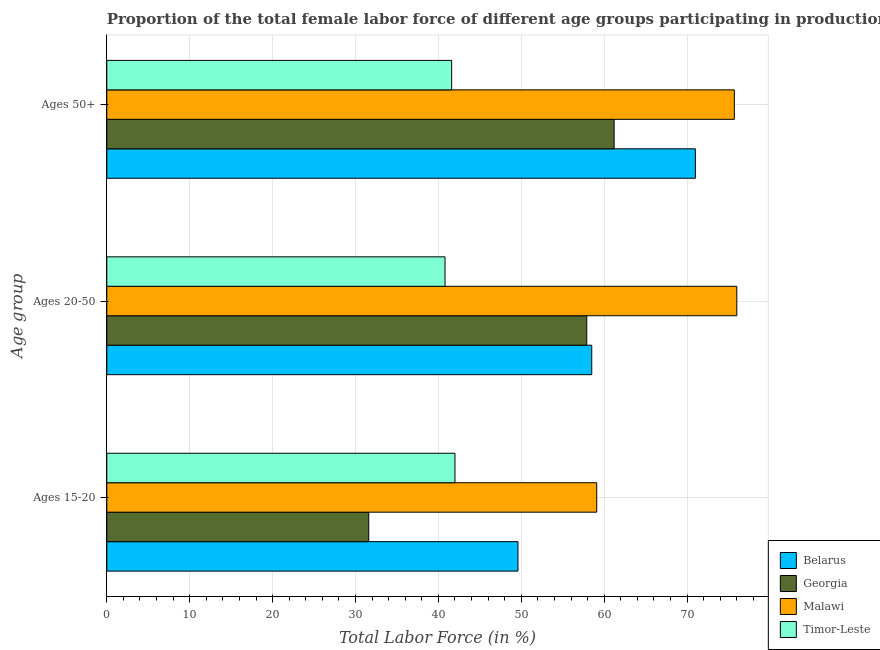Are the number of bars per tick equal to the number of legend labels?
Provide a succinct answer. Yes. How many bars are there on the 3rd tick from the bottom?
Your answer should be very brief. 4. What is the label of the 2nd group of bars from the top?
Make the answer very short. Ages 20-50. What is the percentage of female labor force above age 50 in Georgia?
Offer a very short reply. 61.2. Across all countries, what is the maximum percentage of female labor force within the age group 20-50?
Offer a terse response. 76. Across all countries, what is the minimum percentage of female labor force within the age group 20-50?
Offer a terse response. 40.8. In which country was the percentage of female labor force within the age group 15-20 maximum?
Offer a terse response. Malawi. In which country was the percentage of female labor force within the age group 15-20 minimum?
Provide a short and direct response. Georgia. What is the total percentage of female labor force within the age group 20-50 in the graph?
Make the answer very short. 233.2. What is the difference between the percentage of female labor force above age 50 in Georgia and that in Malawi?
Give a very brief answer. -14.5. What is the difference between the percentage of female labor force above age 50 in Timor-Leste and the percentage of female labor force within the age group 15-20 in Georgia?
Provide a succinct answer. 10. What is the average percentage of female labor force above age 50 per country?
Offer a very short reply. 62.37. In how many countries, is the percentage of female labor force within the age group 15-20 greater than 42 %?
Ensure brevity in your answer.  2. What is the ratio of the percentage of female labor force above age 50 in Belarus to that in Malawi?
Your answer should be very brief. 0.94. Is the percentage of female labor force within the age group 20-50 in Timor-Leste less than that in Georgia?
Your answer should be very brief. Yes. Is the difference between the percentage of female labor force within the age group 20-50 in Belarus and Malawi greater than the difference between the percentage of female labor force within the age group 15-20 in Belarus and Malawi?
Keep it short and to the point. No. What is the difference between the highest and the second highest percentage of female labor force above age 50?
Offer a very short reply. 4.7. What is the difference between the highest and the lowest percentage of female labor force within the age group 20-50?
Keep it short and to the point. 35.2. What does the 1st bar from the top in Ages 20-50 represents?
Make the answer very short. Timor-Leste. What does the 3rd bar from the bottom in Ages 15-20 represents?
Your answer should be very brief. Malawi. How many bars are there?
Your response must be concise. 12. How many countries are there in the graph?
Make the answer very short. 4. What is the difference between two consecutive major ticks on the X-axis?
Provide a short and direct response. 10. Are the values on the major ticks of X-axis written in scientific E-notation?
Offer a terse response. No. Does the graph contain grids?
Give a very brief answer. Yes. How many legend labels are there?
Ensure brevity in your answer.  4. How are the legend labels stacked?
Ensure brevity in your answer.  Vertical. What is the title of the graph?
Make the answer very short. Proportion of the total female labor force of different age groups participating in production in 1992. What is the label or title of the Y-axis?
Make the answer very short. Age group. What is the Total Labor Force (in %) of Belarus in Ages 15-20?
Keep it short and to the point. 49.6. What is the Total Labor Force (in %) of Georgia in Ages 15-20?
Offer a very short reply. 31.6. What is the Total Labor Force (in %) in Malawi in Ages 15-20?
Make the answer very short. 59.1. What is the Total Labor Force (in %) of Belarus in Ages 20-50?
Offer a terse response. 58.5. What is the Total Labor Force (in %) in Georgia in Ages 20-50?
Offer a very short reply. 57.9. What is the Total Labor Force (in %) in Timor-Leste in Ages 20-50?
Provide a short and direct response. 40.8. What is the Total Labor Force (in %) in Georgia in Ages 50+?
Your answer should be very brief. 61.2. What is the Total Labor Force (in %) in Malawi in Ages 50+?
Offer a very short reply. 75.7. What is the Total Labor Force (in %) in Timor-Leste in Ages 50+?
Provide a short and direct response. 41.6. Across all Age group, what is the maximum Total Labor Force (in %) in Belarus?
Give a very brief answer. 71. Across all Age group, what is the maximum Total Labor Force (in %) in Georgia?
Make the answer very short. 61.2. Across all Age group, what is the maximum Total Labor Force (in %) of Malawi?
Ensure brevity in your answer.  76. Across all Age group, what is the minimum Total Labor Force (in %) of Belarus?
Your answer should be very brief. 49.6. Across all Age group, what is the minimum Total Labor Force (in %) in Georgia?
Your answer should be compact. 31.6. Across all Age group, what is the minimum Total Labor Force (in %) of Malawi?
Ensure brevity in your answer.  59.1. Across all Age group, what is the minimum Total Labor Force (in %) in Timor-Leste?
Ensure brevity in your answer.  40.8. What is the total Total Labor Force (in %) in Belarus in the graph?
Make the answer very short. 179.1. What is the total Total Labor Force (in %) in Georgia in the graph?
Give a very brief answer. 150.7. What is the total Total Labor Force (in %) in Malawi in the graph?
Your answer should be very brief. 210.8. What is the total Total Labor Force (in %) in Timor-Leste in the graph?
Make the answer very short. 124.4. What is the difference between the Total Labor Force (in %) of Belarus in Ages 15-20 and that in Ages 20-50?
Ensure brevity in your answer.  -8.9. What is the difference between the Total Labor Force (in %) of Georgia in Ages 15-20 and that in Ages 20-50?
Make the answer very short. -26.3. What is the difference between the Total Labor Force (in %) of Malawi in Ages 15-20 and that in Ages 20-50?
Offer a terse response. -16.9. What is the difference between the Total Labor Force (in %) in Timor-Leste in Ages 15-20 and that in Ages 20-50?
Give a very brief answer. 1.2. What is the difference between the Total Labor Force (in %) in Belarus in Ages 15-20 and that in Ages 50+?
Offer a very short reply. -21.4. What is the difference between the Total Labor Force (in %) in Georgia in Ages 15-20 and that in Ages 50+?
Your answer should be compact. -29.6. What is the difference between the Total Labor Force (in %) in Malawi in Ages 15-20 and that in Ages 50+?
Provide a short and direct response. -16.6. What is the difference between the Total Labor Force (in %) in Malawi in Ages 20-50 and that in Ages 50+?
Your response must be concise. 0.3. What is the difference between the Total Labor Force (in %) in Belarus in Ages 15-20 and the Total Labor Force (in %) in Georgia in Ages 20-50?
Provide a succinct answer. -8.3. What is the difference between the Total Labor Force (in %) of Belarus in Ages 15-20 and the Total Labor Force (in %) of Malawi in Ages 20-50?
Make the answer very short. -26.4. What is the difference between the Total Labor Force (in %) in Georgia in Ages 15-20 and the Total Labor Force (in %) in Malawi in Ages 20-50?
Your answer should be very brief. -44.4. What is the difference between the Total Labor Force (in %) of Georgia in Ages 15-20 and the Total Labor Force (in %) of Timor-Leste in Ages 20-50?
Make the answer very short. -9.2. What is the difference between the Total Labor Force (in %) of Belarus in Ages 15-20 and the Total Labor Force (in %) of Georgia in Ages 50+?
Provide a short and direct response. -11.6. What is the difference between the Total Labor Force (in %) of Belarus in Ages 15-20 and the Total Labor Force (in %) of Malawi in Ages 50+?
Provide a succinct answer. -26.1. What is the difference between the Total Labor Force (in %) of Georgia in Ages 15-20 and the Total Labor Force (in %) of Malawi in Ages 50+?
Your answer should be very brief. -44.1. What is the difference between the Total Labor Force (in %) in Georgia in Ages 15-20 and the Total Labor Force (in %) in Timor-Leste in Ages 50+?
Your answer should be very brief. -10. What is the difference between the Total Labor Force (in %) in Malawi in Ages 15-20 and the Total Labor Force (in %) in Timor-Leste in Ages 50+?
Give a very brief answer. 17.5. What is the difference between the Total Labor Force (in %) in Belarus in Ages 20-50 and the Total Labor Force (in %) in Georgia in Ages 50+?
Provide a short and direct response. -2.7. What is the difference between the Total Labor Force (in %) in Belarus in Ages 20-50 and the Total Labor Force (in %) in Malawi in Ages 50+?
Keep it short and to the point. -17.2. What is the difference between the Total Labor Force (in %) of Belarus in Ages 20-50 and the Total Labor Force (in %) of Timor-Leste in Ages 50+?
Provide a succinct answer. 16.9. What is the difference between the Total Labor Force (in %) in Georgia in Ages 20-50 and the Total Labor Force (in %) in Malawi in Ages 50+?
Your answer should be very brief. -17.8. What is the difference between the Total Labor Force (in %) in Georgia in Ages 20-50 and the Total Labor Force (in %) in Timor-Leste in Ages 50+?
Provide a succinct answer. 16.3. What is the difference between the Total Labor Force (in %) in Malawi in Ages 20-50 and the Total Labor Force (in %) in Timor-Leste in Ages 50+?
Provide a short and direct response. 34.4. What is the average Total Labor Force (in %) of Belarus per Age group?
Ensure brevity in your answer.  59.7. What is the average Total Labor Force (in %) in Georgia per Age group?
Provide a succinct answer. 50.23. What is the average Total Labor Force (in %) of Malawi per Age group?
Provide a short and direct response. 70.27. What is the average Total Labor Force (in %) of Timor-Leste per Age group?
Ensure brevity in your answer.  41.47. What is the difference between the Total Labor Force (in %) in Belarus and Total Labor Force (in %) in Timor-Leste in Ages 15-20?
Your response must be concise. 7.6. What is the difference between the Total Labor Force (in %) of Georgia and Total Labor Force (in %) of Malawi in Ages 15-20?
Provide a succinct answer. -27.5. What is the difference between the Total Labor Force (in %) of Georgia and Total Labor Force (in %) of Timor-Leste in Ages 15-20?
Make the answer very short. -10.4. What is the difference between the Total Labor Force (in %) of Malawi and Total Labor Force (in %) of Timor-Leste in Ages 15-20?
Your answer should be very brief. 17.1. What is the difference between the Total Labor Force (in %) in Belarus and Total Labor Force (in %) in Georgia in Ages 20-50?
Your answer should be very brief. 0.6. What is the difference between the Total Labor Force (in %) of Belarus and Total Labor Force (in %) of Malawi in Ages 20-50?
Make the answer very short. -17.5. What is the difference between the Total Labor Force (in %) in Georgia and Total Labor Force (in %) in Malawi in Ages 20-50?
Provide a short and direct response. -18.1. What is the difference between the Total Labor Force (in %) in Georgia and Total Labor Force (in %) in Timor-Leste in Ages 20-50?
Provide a succinct answer. 17.1. What is the difference between the Total Labor Force (in %) in Malawi and Total Labor Force (in %) in Timor-Leste in Ages 20-50?
Provide a succinct answer. 35.2. What is the difference between the Total Labor Force (in %) in Belarus and Total Labor Force (in %) in Georgia in Ages 50+?
Keep it short and to the point. 9.8. What is the difference between the Total Labor Force (in %) of Belarus and Total Labor Force (in %) of Malawi in Ages 50+?
Keep it short and to the point. -4.7. What is the difference between the Total Labor Force (in %) of Belarus and Total Labor Force (in %) of Timor-Leste in Ages 50+?
Your response must be concise. 29.4. What is the difference between the Total Labor Force (in %) of Georgia and Total Labor Force (in %) of Timor-Leste in Ages 50+?
Offer a terse response. 19.6. What is the difference between the Total Labor Force (in %) in Malawi and Total Labor Force (in %) in Timor-Leste in Ages 50+?
Your response must be concise. 34.1. What is the ratio of the Total Labor Force (in %) of Belarus in Ages 15-20 to that in Ages 20-50?
Your response must be concise. 0.85. What is the ratio of the Total Labor Force (in %) of Georgia in Ages 15-20 to that in Ages 20-50?
Ensure brevity in your answer.  0.55. What is the ratio of the Total Labor Force (in %) of Malawi in Ages 15-20 to that in Ages 20-50?
Provide a succinct answer. 0.78. What is the ratio of the Total Labor Force (in %) in Timor-Leste in Ages 15-20 to that in Ages 20-50?
Keep it short and to the point. 1.03. What is the ratio of the Total Labor Force (in %) in Belarus in Ages 15-20 to that in Ages 50+?
Your answer should be very brief. 0.7. What is the ratio of the Total Labor Force (in %) in Georgia in Ages 15-20 to that in Ages 50+?
Provide a succinct answer. 0.52. What is the ratio of the Total Labor Force (in %) of Malawi in Ages 15-20 to that in Ages 50+?
Your answer should be very brief. 0.78. What is the ratio of the Total Labor Force (in %) in Timor-Leste in Ages 15-20 to that in Ages 50+?
Provide a short and direct response. 1.01. What is the ratio of the Total Labor Force (in %) in Belarus in Ages 20-50 to that in Ages 50+?
Your answer should be very brief. 0.82. What is the ratio of the Total Labor Force (in %) of Georgia in Ages 20-50 to that in Ages 50+?
Give a very brief answer. 0.95. What is the ratio of the Total Labor Force (in %) in Timor-Leste in Ages 20-50 to that in Ages 50+?
Your answer should be compact. 0.98. What is the difference between the highest and the second highest Total Labor Force (in %) of Georgia?
Offer a terse response. 3.3. What is the difference between the highest and the second highest Total Labor Force (in %) of Malawi?
Ensure brevity in your answer.  0.3. What is the difference between the highest and the lowest Total Labor Force (in %) of Belarus?
Keep it short and to the point. 21.4. What is the difference between the highest and the lowest Total Labor Force (in %) of Georgia?
Keep it short and to the point. 29.6. What is the difference between the highest and the lowest Total Labor Force (in %) in Timor-Leste?
Provide a short and direct response. 1.2. 